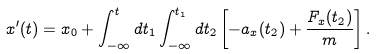Convert formula to latex. <formula><loc_0><loc_0><loc_500><loc_500>x ^ { \prime } ( t ) = x _ { 0 } + \int _ { - \infty } ^ { t } d t _ { 1 } \int _ { - \infty } ^ { t _ { 1 } } d t _ { 2 } \left [ - a _ { x } ( t _ { 2 } ) + \frac { F _ { x } ( t _ { 2 } ) } { m } \right ] .</formula> 